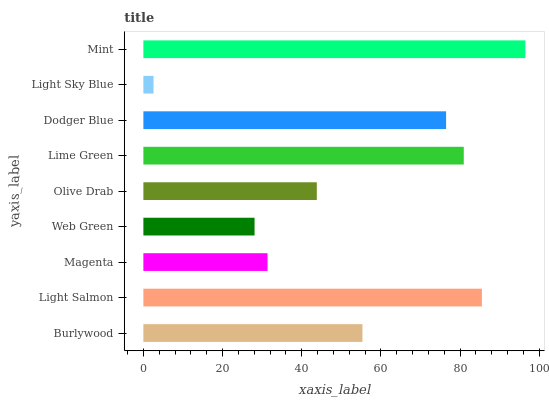Is Light Sky Blue the minimum?
Answer yes or no. Yes. Is Mint the maximum?
Answer yes or no. Yes. Is Light Salmon the minimum?
Answer yes or no. No. Is Light Salmon the maximum?
Answer yes or no. No. Is Light Salmon greater than Burlywood?
Answer yes or no. Yes. Is Burlywood less than Light Salmon?
Answer yes or no. Yes. Is Burlywood greater than Light Salmon?
Answer yes or no. No. Is Light Salmon less than Burlywood?
Answer yes or no. No. Is Burlywood the high median?
Answer yes or no. Yes. Is Burlywood the low median?
Answer yes or no. Yes. Is Olive Drab the high median?
Answer yes or no. No. Is Dodger Blue the low median?
Answer yes or no. No. 